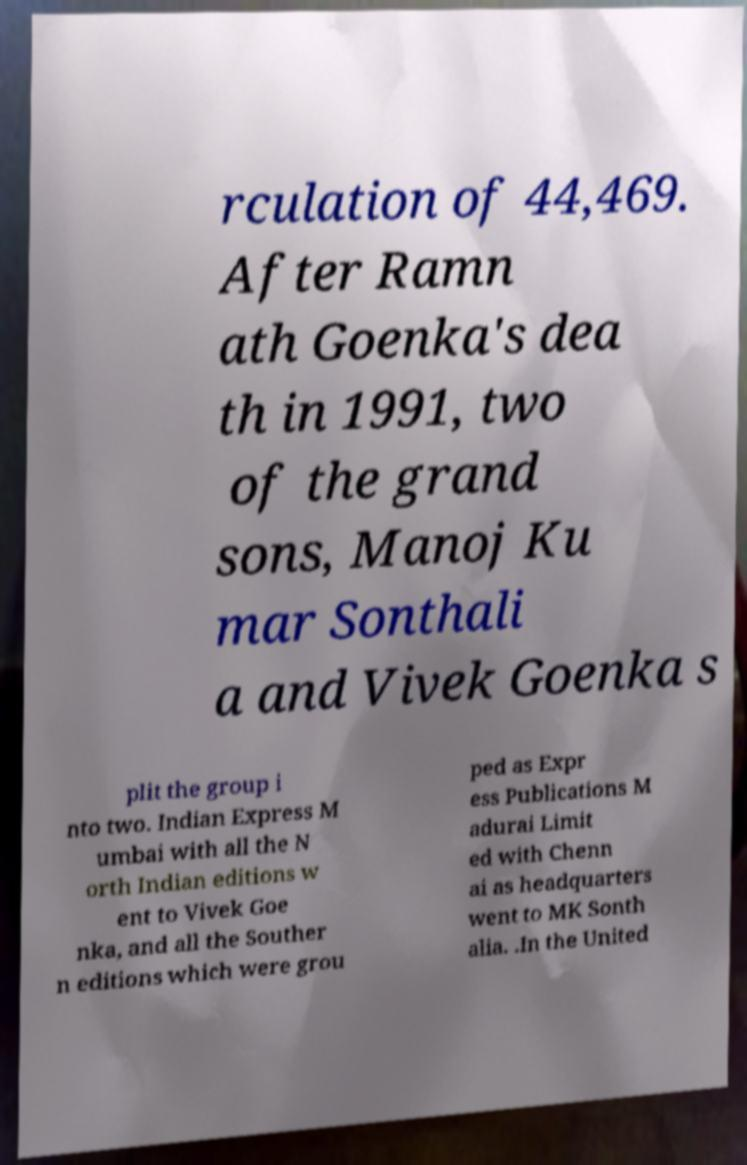Can you read and provide the text displayed in the image?This photo seems to have some interesting text. Can you extract and type it out for me? rculation of 44,469. After Ramn ath Goenka's dea th in 1991, two of the grand sons, Manoj Ku mar Sonthali a and Vivek Goenka s plit the group i nto two. Indian Express M umbai with all the N orth Indian editions w ent to Vivek Goe nka, and all the Souther n editions which were grou ped as Expr ess Publications M adurai Limit ed with Chenn ai as headquarters went to MK Sonth alia. .In the United 